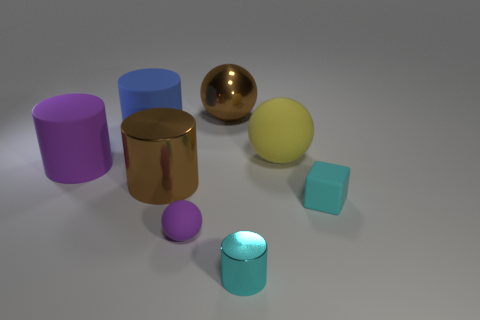Add 2 tiny brown blocks. How many objects exist? 10 Subtract all blocks. How many objects are left? 7 Subtract all purple things. Subtract all large purple rubber cylinders. How many objects are left? 5 Add 5 big blue rubber things. How many big blue rubber things are left? 6 Add 1 large gray blocks. How many large gray blocks exist? 1 Subtract 1 blue cylinders. How many objects are left? 7 